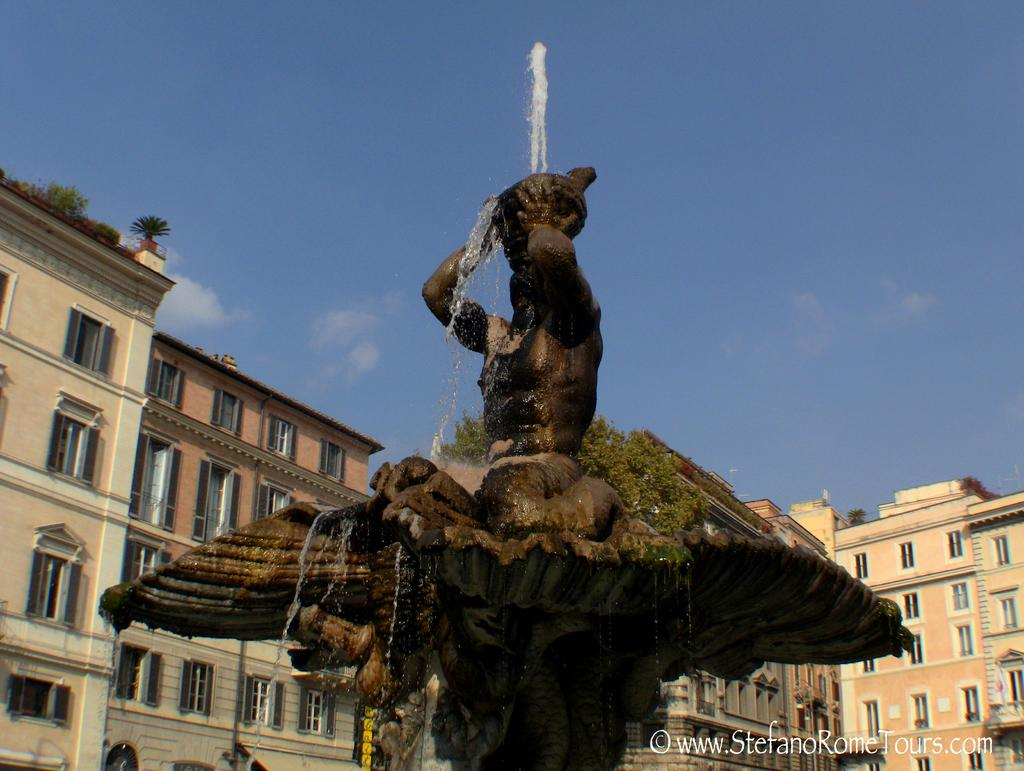What is the main feature in the image? There is a fountain in the image. What colors are used to depict the fountain? The fountain is in brown and black color. What can be seen in the background of the image? There are buildings, windows, and green plants visible in the background. What is the color of the sky in the image? The sky is blue and white in color. Can you tell me how many ears of corn are growing near the fountain in the image? There are no ears of corn present in the image; it features a fountain, buildings, windows, green plants, and a blue and white sky. What type of damage might the fountain have sustained during the earthquake in the image? There is no earthquake depicted in the image, and therefore no damage can be observed. 